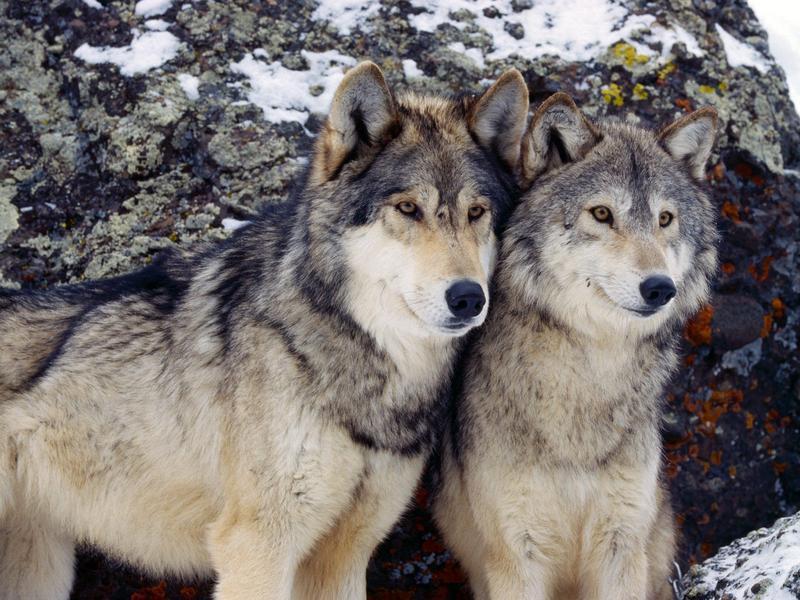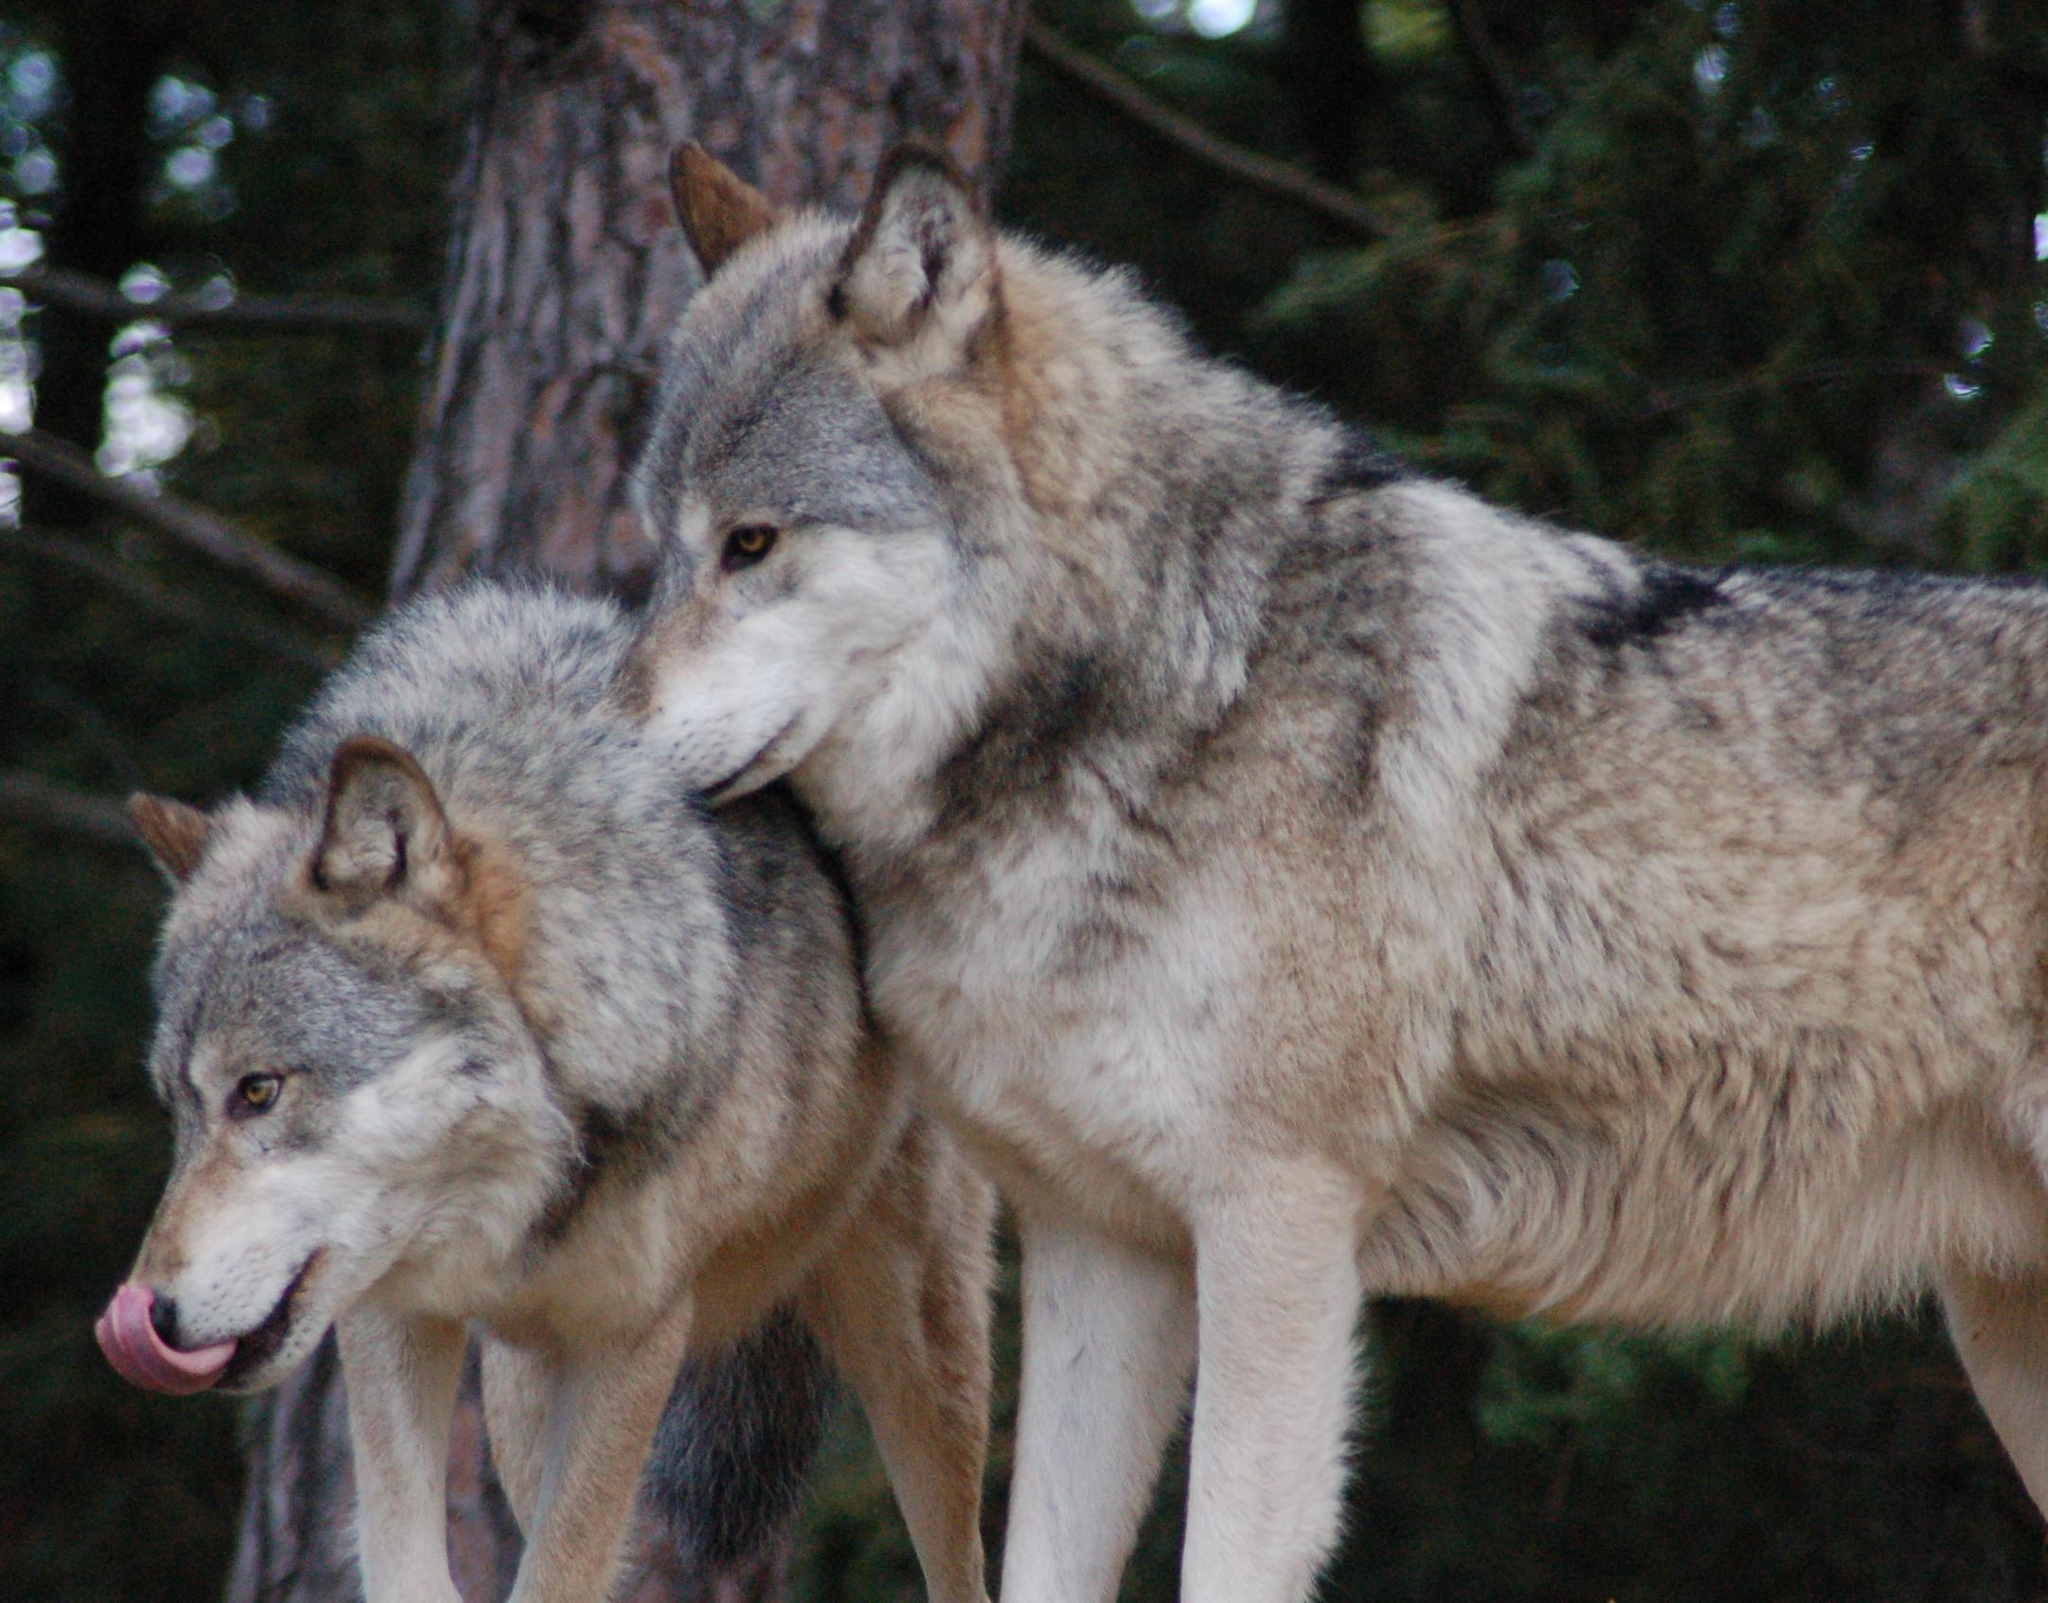The first image is the image on the left, the second image is the image on the right. Given the left and right images, does the statement "There are a total of four wolves." hold true? Answer yes or no. Yes. The first image is the image on the left, the second image is the image on the right. Considering the images on both sides, is "There are at most two wolves total" valid? Answer yes or no. No. 